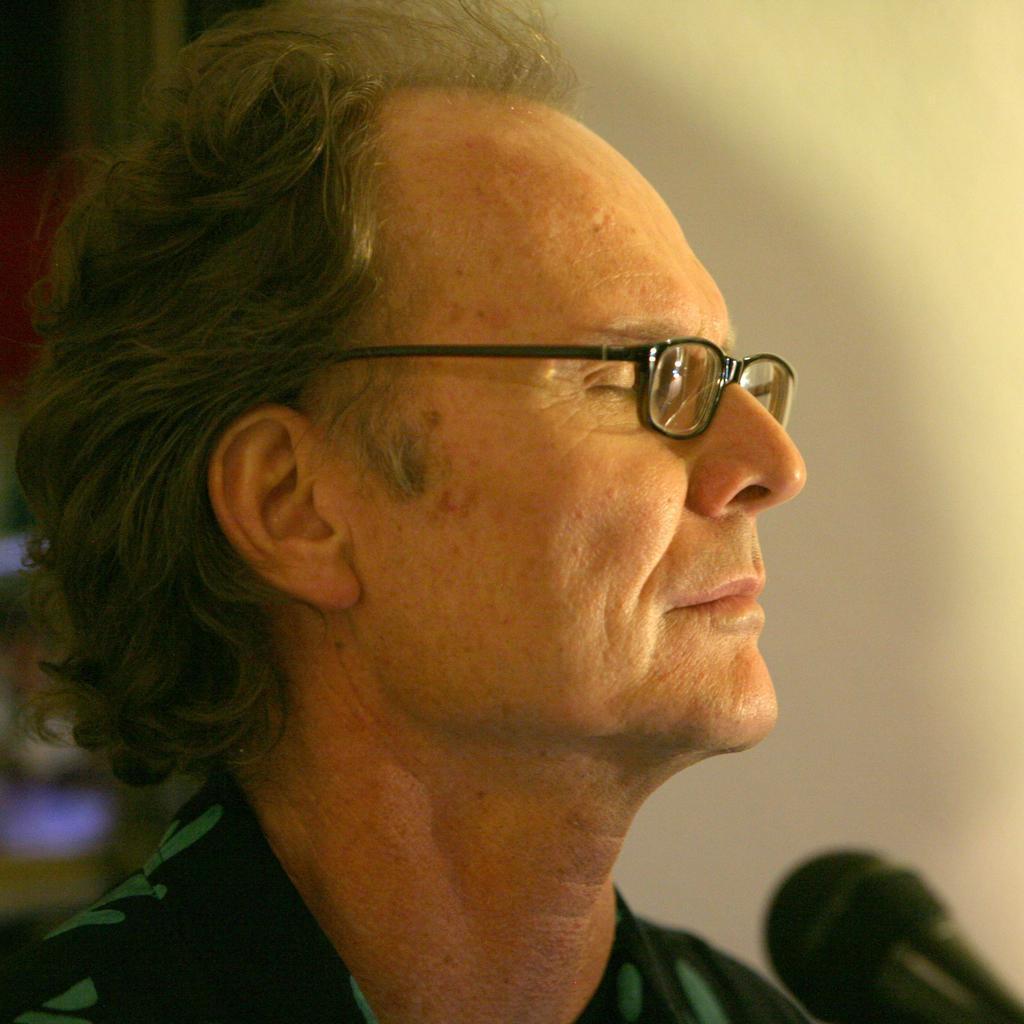Who is present in the image? There is a man in the image. What is the man wearing? The man is wearing spectacles. What object is in front of the man? There is a microphone in front of the man. What can be seen behind the man? There is a wall in the background of the image, and there are objects visible in the background. How many horses are visible in the image? There are no horses present in the image. What type of salt is being used by the man in the image? There is no salt visible in the image, and the man's actions are not described. 